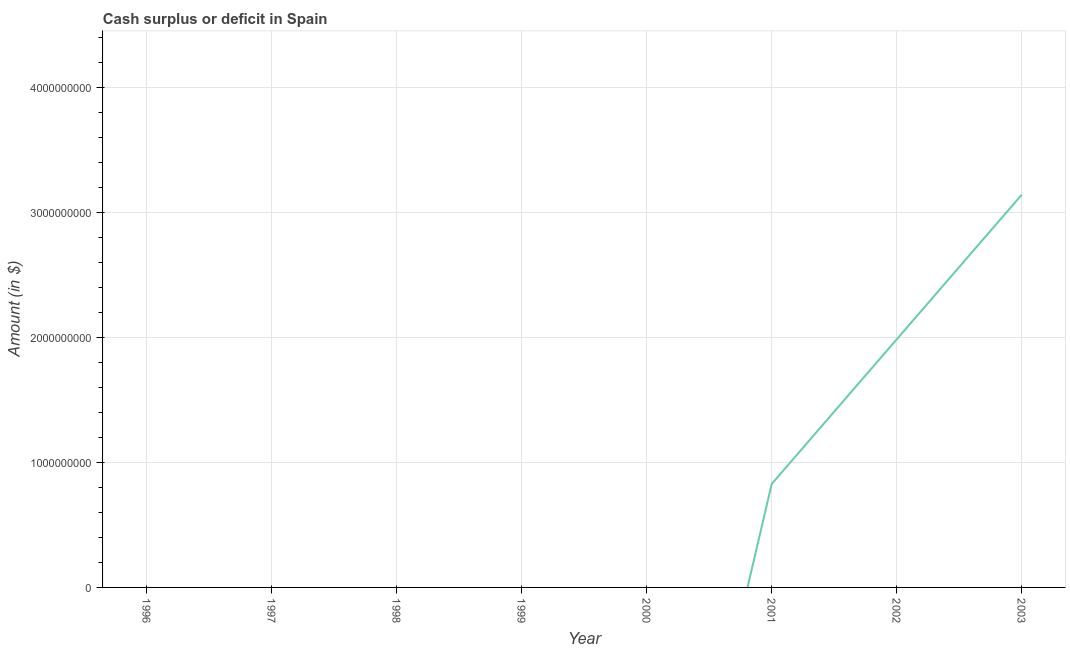What is the cash surplus or deficit in 2003?
Your response must be concise. 3.14e+09. Across all years, what is the maximum cash surplus or deficit?
Keep it short and to the point. 3.14e+09. What is the sum of the cash surplus or deficit?
Give a very brief answer. 5.96e+09. What is the difference between the cash surplus or deficit in 2001 and 2002?
Your response must be concise. -1.16e+09. What is the average cash surplus or deficit per year?
Make the answer very short. 7.44e+08. What is the median cash surplus or deficit?
Your answer should be compact. 0. In how many years, is the cash surplus or deficit greater than 2000000000 $?
Provide a short and direct response. 1. What is the ratio of the cash surplus or deficit in 2002 to that in 2003?
Provide a short and direct response. 0.63. What is the difference between the highest and the second highest cash surplus or deficit?
Make the answer very short. 1.16e+09. What is the difference between the highest and the lowest cash surplus or deficit?
Provide a short and direct response. 3.14e+09. Does the cash surplus or deficit monotonically increase over the years?
Offer a very short reply. Yes. How many lines are there?
Make the answer very short. 1. Are the values on the major ticks of Y-axis written in scientific E-notation?
Offer a very short reply. No. What is the title of the graph?
Your answer should be very brief. Cash surplus or deficit in Spain. What is the label or title of the Y-axis?
Ensure brevity in your answer.  Amount (in $). What is the Amount (in $) of 1996?
Make the answer very short. 0. What is the Amount (in $) of 1999?
Offer a very short reply. 0. What is the Amount (in $) of 2001?
Give a very brief answer. 8.28e+08. What is the Amount (in $) of 2002?
Offer a terse response. 1.98e+09. What is the Amount (in $) in 2003?
Ensure brevity in your answer.  3.14e+09. What is the difference between the Amount (in $) in 2001 and 2002?
Your response must be concise. -1.16e+09. What is the difference between the Amount (in $) in 2001 and 2003?
Your answer should be very brief. -2.31e+09. What is the difference between the Amount (in $) in 2002 and 2003?
Provide a succinct answer. -1.16e+09. What is the ratio of the Amount (in $) in 2001 to that in 2002?
Offer a terse response. 0.42. What is the ratio of the Amount (in $) in 2001 to that in 2003?
Your answer should be compact. 0.26. What is the ratio of the Amount (in $) in 2002 to that in 2003?
Provide a short and direct response. 0.63. 